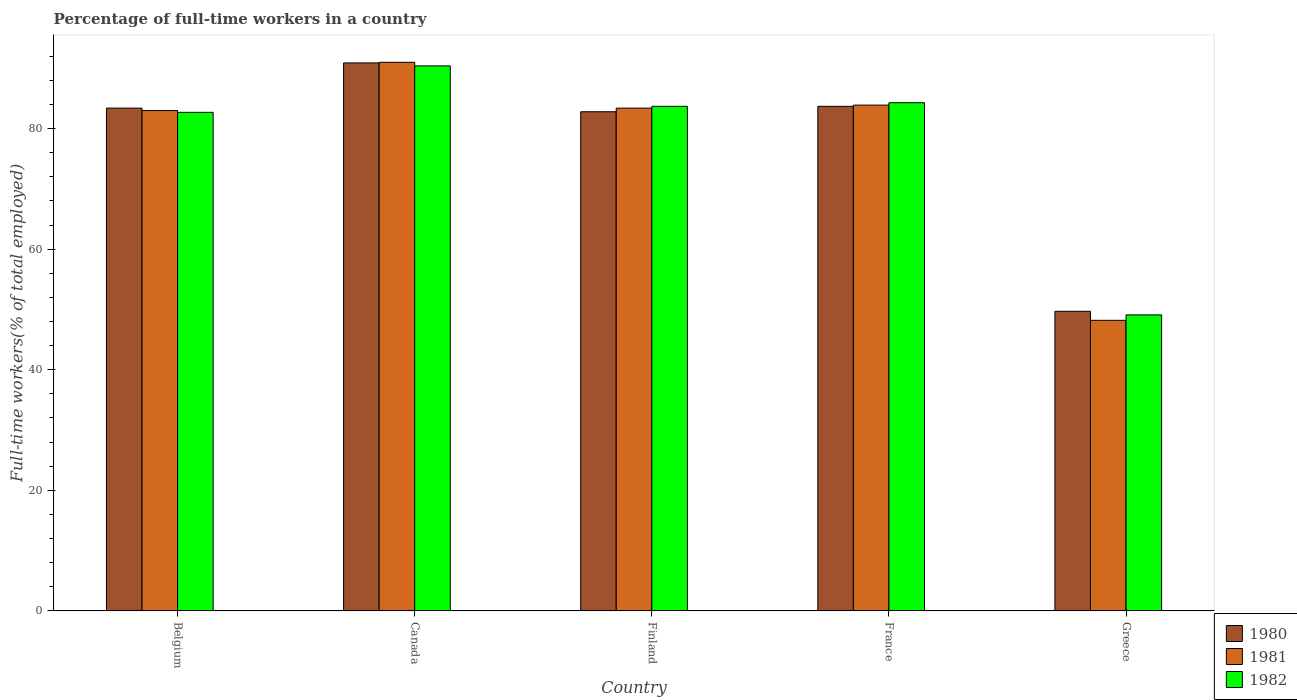Are the number of bars per tick equal to the number of legend labels?
Make the answer very short. Yes. Are the number of bars on each tick of the X-axis equal?
Offer a terse response. Yes. How many bars are there on the 2nd tick from the right?
Offer a very short reply. 3. What is the percentage of full-time workers in 1981 in Canada?
Your response must be concise. 91. Across all countries, what is the maximum percentage of full-time workers in 1982?
Provide a short and direct response. 90.4. Across all countries, what is the minimum percentage of full-time workers in 1980?
Make the answer very short. 49.7. In which country was the percentage of full-time workers in 1981 maximum?
Your answer should be very brief. Canada. In which country was the percentage of full-time workers in 1982 minimum?
Your answer should be compact. Greece. What is the total percentage of full-time workers in 1982 in the graph?
Ensure brevity in your answer.  390.2. What is the difference between the percentage of full-time workers in 1982 in France and that in Greece?
Keep it short and to the point. 35.2. What is the difference between the percentage of full-time workers in 1982 in Greece and the percentage of full-time workers in 1981 in France?
Ensure brevity in your answer.  -34.8. What is the average percentage of full-time workers in 1980 per country?
Keep it short and to the point. 78.1. What is the difference between the percentage of full-time workers of/in 1982 and percentage of full-time workers of/in 1980 in France?
Make the answer very short. 0.6. In how many countries, is the percentage of full-time workers in 1982 greater than 68 %?
Your answer should be very brief. 4. What is the ratio of the percentage of full-time workers in 1980 in France to that in Greece?
Your response must be concise. 1.68. Is the percentage of full-time workers in 1980 in France less than that in Greece?
Give a very brief answer. No. Is the difference between the percentage of full-time workers in 1982 in Belgium and Canada greater than the difference between the percentage of full-time workers in 1980 in Belgium and Canada?
Provide a succinct answer. No. What is the difference between the highest and the second highest percentage of full-time workers in 1980?
Offer a very short reply. -7.5. What is the difference between the highest and the lowest percentage of full-time workers in 1980?
Ensure brevity in your answer.  41.2. Is the sum of the percentage of full-time workers in 1982 in Belgium and Greece greater than the maximum percentage of full-time workers in 1981 across all countries?
Provide a succinct answer. Yes. What does the 1st bar from the right in France represents?
Make the answer very short. 1982. How many bars are there?
Your answer should be compact. 15. Are all the bars in the graph horizontal?
Offer a very short reply. No. How many countries are there in the graph?
Make the answer very short. 5. Does the graph contain grids?
Provide a succinct answer. No. Where does the legend appear in the graph?
Ensure brevity in your answer.  Bottom right. How many legend labels are there?
Your answer should be compact. 3. How are the legend labels stacked?
Make the answer very short. Vertical. What is the title of the graph?
Offer a terse response. Percentage of full-time workers in a country. Does "1973" appear as one of the legend labels in the graph?
Offer a very short reply. No. What is the label or title of the X-axis?
Make the answer very short. Country. What is the label or title of the Y-axis?
Your answer should be very brief. Full-time workers(% of total employed). What is the Full-time workers(% of total employed) in 1980 in Belgium?
Make the answer very short. 83.4. What is the Full-time workers(% of total employed) of 1982 in Belgium?
Your answer should be compact. 82.7. What is the Full-time workers(% of total employed) in 1980 in Canada?
Your answer should be very brief. 90.9. What is the Full-time workers(% of total employed) of 1981 in Canada?
Ensure brevity in your answer.  91. What is the Full-time workers(% of total employed) in 1982 in Canada?
Give a very brief answer. 90.4. What is the Full-time workers(% of total employed) of 1980 in Finland?
Offer a terse response. 82.8. What is the Full-time workers(% of total employed) in 1981 in Finland?
Make the answer very short. 83.4. What is the Full-time workers(% of total employed) of 1982 in Finland?
Provide a short and direct response. 83.7. What is the Full-time workers(% of total employed) of 1980 in France?
Provide a succinct answer. 83.7. What is the Full-time workers(% of total employed) in 1981 in France?
Ensure brevity in your answer.  83.9. What is the Full-time workers(% of total employed) of 1982 in France?
Keep it short and to the point. 84.3. What is the Full-time workers(% of total employed) of 1980 in Greece?
Keep it short and to the point. 49.7. What is the Full-time workers(% of total employed) of 1981 in Greece?
Your response must be concise. 48.2. What is the Full-time workers(% of total employed) of 1982 in Greece?
Your response must be concise. 49.1. Across all countries, what is the maximum Full-time workers(% of total employed) of 1980?
Your response must be concise. 90.9. Across all countries, what is the maximum Full-time workers(% of total employed) in 1981?
Make the answer very short. 91. Across all countries, what is the maximum Full-time workers(% of total employed) in 1982?
Keep it short and to the point. 90.4. Across all countries, what is the minimum Full-time workers(% of total employed) of 1980?
Keep it short and to the point. 49.7. Across all countries, what is the minimum Full-time workers(% of total employed) of 1981?
Give a very brief answer. 48.2. Across all countries, what is the minimum Full-time workers(% of total employed) in 1982?
Give a very brief answer. 49.1. What is the total Full-time workers(% of total employed) in 1980 in the graph?
Offer a very short reply. 390.5. What is the total Full-time workers(% of total employed) in 1981 in the graph?
Offer a terse response. 389.5. What is the total Full-time workers(% of total employed) in 1982 in the graph?
Your answer should be compact. 390.2. What is the difference between the Full-time workers(% of total employed) of 1980 in Belgium and that in Canada?
Make the answer very short. -7.5. What is the difference between the Full-time workers(% of total employed) in 1982 in Belgium and that in Canada?
Your answer should be compact. -7.7. What is the difference between the Full-time workers(% of total employed) of 1980 in Belgium and that in Finland?
Your response must be concise. 0.6. What is the difference between the Full-time workers(% of total employed) of 1980 in Belgium and that in France?
Provide a short and direct response. -0.3. What is the difference between the Full-time workers(% of total employed) of 1980 in Belgium and that in Greece?
Ensure brevity in your answer.  33.7. What is the difference between the Full-time workers(% of total employed) of 1981 in Belgium and that in Greece?
Your response must be concise. 34.8. What is the difference between the Full-time workers(% of total employed) in 1982 in Belgium and that in Greece?
Your answer should be compact. 33.6. What is the difference between the Full-time workers(% of total employed) of 1980 in Canada and that in Finland?
Give a very brief answer. 8.1. What is the difference between the Full-time workers(% of total employed) of 1981 in Canada and that in Finland?
Your answer should be compact. 7.6. What is the difference between the Full-time workers(% of total employed) of 1981 in Canada and that in France?
Your answer should be compact. 7.1. What is the difference between the Full-time workers(% of total employed) in 1980 in Canada and that in Greece?
Ensure brevity in your answer.  41.2. What is the difference between the Full-time workers(% of total employed) in 1981 in Canada and that in Greece?
Provide a short and direct response. 42.8. What is the difference between the Full-time workers(% of total employed) of 1982 in Canada and that in Greece?
Your response must be concise. 41.3. What is the difference between the Full-time workers(% of total employed) of 1980 in Finland and that in France?
Ensure brevity in your answer.  -0.9. What is the difference between the Full-time workers(% of total employed) of 1980 in Finland and that in Greece?
Ensure brevity in your answer.  33.1. What is the difference between the Full-time workers(% of total employed) of 1981 in Finland and that in Greece?
Provide a short and direct response. 35.2. What is the difference between the Full-time workers(% of total employed) in 1982 in Finland and that in Greece?
Provide a short and direct response. 34.6. What is the difference between the Full-time workers(% of total employed) of 1981 in France and that in Greece?
Your answer should be compact. 35.7. What is the difference between the Full-time workers(% of total employed) of 1982 in France and that in Greece?
Provide a succinct answer. 35.2. What is the difference between the Full-time workers(% of total employed) of 1980 in Belgium and the Full-time workers(% of total employed) of 1982 in Finland?
Provide a succinct answer. -0.3. What is the difference between the Full-time workers(% of total employed) in 1981 in Belgium and the Full-time workers(% of total employed) in 1982 in Finland?
Offer a terse response. -0.7. What is the difference between the Full-time workers(% of total employed) of 1981 in Belgium and the Full-time workers(% of total employed) of 1982 in France?
Keep it short and to the point. -1.3. What is the difference between the Full-time workers(% of total employed) of 1980 in Belgium and the Full-time workers(% of total employed) of 1981 in Greece?
Your answer should be very brief. 35.2. What is the difference between the Full-time workers(% of total employed) of 1980 in Belgium and the Full-time workers(% of total employed) of 1982 in Greece?
Give a very brief answer. 34.3. What is the difference between the Full-time workers(% of total employed) of 1981 in Belgium and the Full-time workers(% of total employed) of 1982 in Greece?
Your response must be concise. 33.9. What is the difference between the Full-time workers(% of total employed) of 1980 in Canada and the Full-time workers(% of total employed) of 1981 in Finland?
Keep it short and to the point. 7.5. What is the difference between the Full-time workers(% of total employed) in 1981 in Canada and the Full-time workers(% of total employed) in 1982 in France?
Your response must be concise. 6.7. What is the difference between the Full-time workers(% of total employed) in 1980 in Canada and the Full-time workers(% of total employed) in 1981 in Greece?
Offer a very short reply. 42.7. What is the difference between the Full-time workers(% of total employed) in 1980 in Canada and the Full-time workers(% of total employed) in 1982 in Greece?
Your response must be concise. 41.8. What is the difference between the Full-time workers(% of total employed) in 1981 in Canada and the Full-time workers(% of total employed) in 1982 in Greece?
Your answer should be very brief. 41.9. What is the difference between the Full-time workers(% of total employed) in 1981 in Finland and the Full-time workers(% of total employed) in 1982 in France?
Give a very brief answer. -0.9. What is the difference between the Full-time workers(% of total employed) in 1980 in Finland and the Full-time workers(% of total employed) in 1981 in Greece?
Offer a very short reply. 34.6. What is the difference between the Full-time workers(% of total employed) in 1980 in Finland and the Full-time workers(% of total employed) in 1982 in Greece?
Your answer should be compact. 33.7. What is the difference between the Full-time workers(% of total employed) of 1981 in Finland and the Full-time workers(% of total employed) of 1982 in Greece?
Keep it short and to the point. 34.3. What is the difference between the Full-time workers(% of total employed) in 1980 in France and the Full-time workers(% of total employed) in 1981 in Greece?
Your response must be concise. 35.5. What is the difference between the Full-time workers(% of total employed) in 1980 in France and the Full-time workers(% of total employed) in 1982 in Greece?
Offer a terse response. 34.6. What is the difference between the Full-time workers(% of total employed) in 1981 in France and the Full-time workers(% of total employed) in 1982 in Greece?
Give a very brief answer. 34.8. What is the average Full-time workers(% of total employed) of 1980 per country?
Your response must be concise. 78.1. What is the average Full-time workers(% of total employed) of 1981 per country?
Keep it short and to the point. 77.9. What is the average Full-time workers(% of total employed) in 1982 per country?
Your answer should be compact. 78.04. What is the difference between the Full-time workers(% of total employed) of 1980 and Full-time workers(% of total employed) of 1981 in Belgium?
Ensure brevity in your answer.  0.4. What is the difference between the Full-time workers(% of total employed) in 1981 and Full-time workers(% of total employed) in 1982 in Canada?
Your answer should be very brief. 0.6. What is the difference between the Full-time workers(% of total employed) of 1980 and Full-time workers(% of total employed) of 1981 in Finland?
Offer a terse response. -0.6. What is the difference between the Full-time workers(% of total employed) in 1980 and Full-time workers(% of total employed) in 1981 in France?
Make the answer very short. -0.2. What is the difference between the Full-time workers(% of total employed) in 1980 and Full-time workers(% of total employed) in 1982 in France?
Make the answer very short. -0.6. What is the difference between the Full-time workers(% of total employed) in 1981 and Full-time workers(% of total employed) in 1982 in France?
Offer a very short reply. -0.4. What is the ratio of the Full-time workers(% of total employed) in 1980 in Belgium to that in Canada?
Keep it short and to the point. 0.92. What is the ratio of the Full-time workers(% of total employed) in 1981 in Belgium to that in Canada?
Ensure brevity in your answer.  0.91. What is the ratio of the Full-time workers(% of total employed) of 1982 in Belgium to that in Canada?
Your response must be concise. 0.91. What is the ratio of the Full-time workers(% of total employed) in 1981 in Belgium to that in Finland?
Make the answer very short. 1. What is the ratio of the Full-time workers(% of total employed) in 1982 in Belgium to that in Finland?
Offer a very short reply. 0.99. What is the ratio of the Full-time workers(% of total employed) in 1980 in Belgium to that in France?
Give a very brief answer. 1. What is the ratio of the Full-time workers(% of total employed) of 1981 in Belgium to that in France?
Provide a succinct answer. 0.99. What is the ratio of the Full-time workers(% of total employed) of 1982 in Belgium to that in France?
Make the answer very short. 0.98. What is the ratio of the Full-time workers(% of total employed) in 1980 in Belgium to that in Greece?
Provide a short and direct response. 1.68. What is the ratio of the Full-time workers(% of total employed) in 1981 in Belgium to that in Greece?
Your answer should be compact. 1.72. What is the ratio of the Full-time workers(% of total employed) in 1982 in Belgium to that in Greece?
Your answer should be very brief. 1.68. What is the ratio of the Full-time workers(% of total employed) in 1980 in Canada to that in Finland?
Keep it short and to the point. 1.1. What is the ratio of the Full-time workers(% of total employed) in 1981 in Canada to that in Finland?
Your response must be concise. 1.09. What is the ratio of the Full-time workers(% of total employed) in 1982 in Canada to that in Finland?
Give a very brief answer. 1.08. What is the ratio of the Full-time workers(% of total employed) in 1980 in Canada to that in France?
Offer a terse response. 1.09. What is the ratio of the Full-time workers(% of total employed) in 1981 in Canada to that in France?
Keep it short and to the point. 1.08. What is the ratio of the Full-time workers(% of total employed) of 1982 in Canada to that in France?
Offer a very short reply. 1.07. What is the ratio of the Full-time workers(% of total employed) of 1980 in Canada to that in Greece?
Your answer should be very brief. 1.83. What is the ratio of the Full-time workers(% of total employed) of 1981 in Canada to that in Greece?
Your answer should be compact. 1.89. What is the ratio of the Full-time workers(% of total employed) in 1982 in Canada to that in Greece?
Offer a very short reply. 1.84. What is the ratio of the Full-time workers(% of total employed) of 1980 in Finland to that in France?
Keep it short and to the point. 0.99. What is the ratio of the Full-time workers(% of total employed) of 1981 in Finland to that in France?
Provide a short and direct response. 0.99. What is the ratio of the Full-time workers(% of total employed) in 1980 in Finland to that in Greece?
Provide a succinct answer. 1.67. What is the ratio of the Full-time workers(% of total employed) in 1981 in Finland to that in Greece?
Make the answer very short. 1.73. What is the ratio of the Full-time workers(% of total employed) of 1982 in Finland to that in Greece?
Offer a very short reply. 1.7. What is the ratio of the Full-time workers(% of total employed) in 1980 in France to that in Greece?
Provide a short and direct response. 1.68. What is the ratio of the Full-time workers(% of total employed) in 1981 in France to that in Greece?
Offer a terse response. 1.74. What is the ratio of the Full-time workers(% of total employed) of 1982 in France to that in Greece?
Keep it short and to the point. 1.72. What is the difference between the highest and the second highest Full-time workers(% of total employed) in 1980?
Give a very brief answer. 7.2. What is the difference between the highest and the lowest Full-time workers(% of total employed) in 1980?
Make the answer very short. 41.2. What is the difference between the highest and the lowest Full-time workers(% of total employed) of 1981?
Keep it short and to the point. 42.8. What is the difference between the highest and the lowest Full-time workers(% of total employed) of 1982?
Your response must be concise. 41.3. 